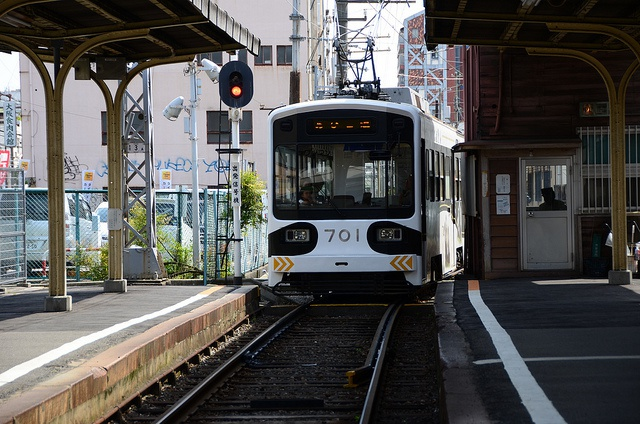Describe the objects in this image and their specific colors. I can see train in black, darkgray, gray, and lightgray tones, car in black, darkgray, gray, and lightblue tones, car in black, darkgray, lightgray, olive, and gray tones, people in black and gray tones, and traffic light in black, orange, khaki, and maroon tones in this image. 